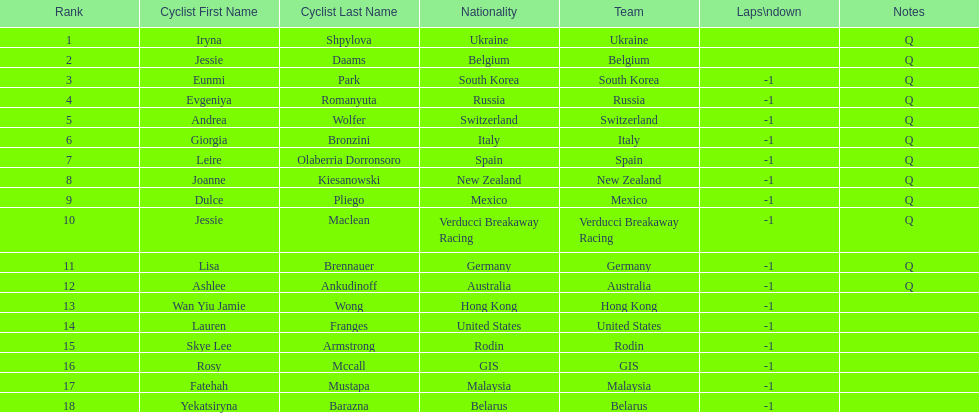How many cyclist are not listed with a country team? 3. 